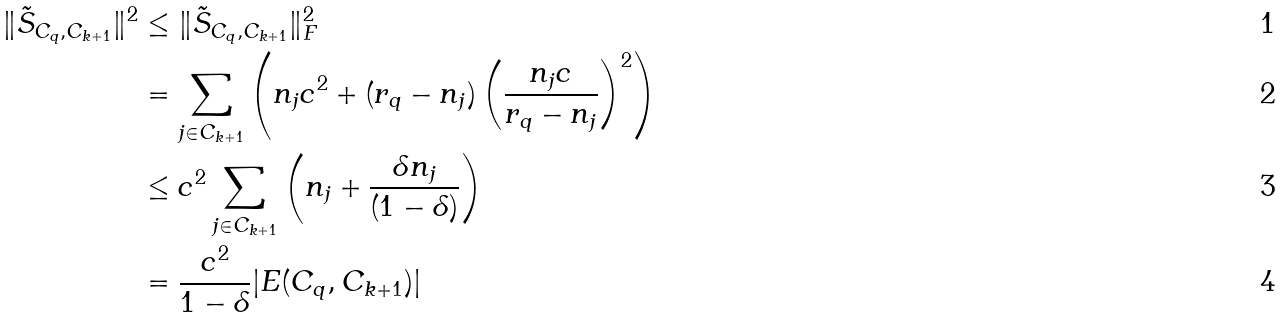Convert formula to latex. <formula><loc_0><loc_0><loc_500><loc_500>\| \tilde { S } _ { C _ { q } , C _ { k + 1 } } \| ^ { 2 } & \leq \| \tilde { S } _ { C _ { q } , C _ { k + 1 } } \| ^ { 2 } _ { F } \\ & = \sum _ { j \in C _ { k + 1 } } \left ( n _ { j } c ^ { 2 } + ( r _ { q } - n _ { j } ) \left ( \frac { n _ { j } c } { r _ { q } - n _ { j } } \right ) ^ { 2 } \right ) \\ & \leq c ^ { 2 } \sum _ { j \in C _ { k + 1 } } \left ( n _ { j } + \frac { \delta n _ { j } } { ( 1 - \delta ) } \right ) \\ & = \frac { c ^ { 2 } } { 1 - \delta } | E ( C _ { q } , C _ { k + 1 } ) |</formula> 